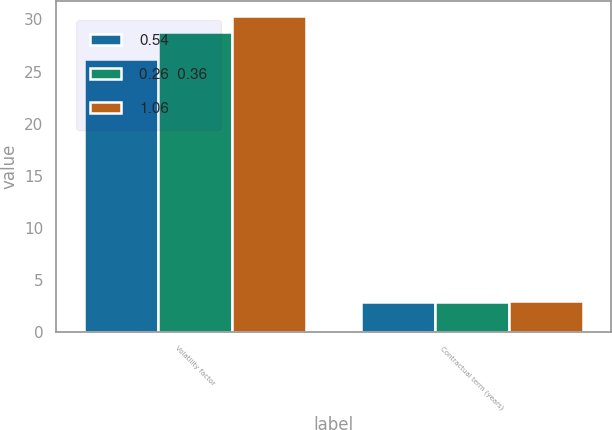Convert chart to OTSL. <chart><loc_0><loc_0><loc_500><loc_500><stacked_bar_chart><ecel><fcel>Volatility factor<fcel>Contractual term (years)<nl><fcel>0.54<fcel>26.2<fcel>2.89<nl><fcel>0.26  0.36<fcel>28.8<fcel>2.89<nl><fcel>1.06<fcel>30.3<fcel>3<nl></chart> 